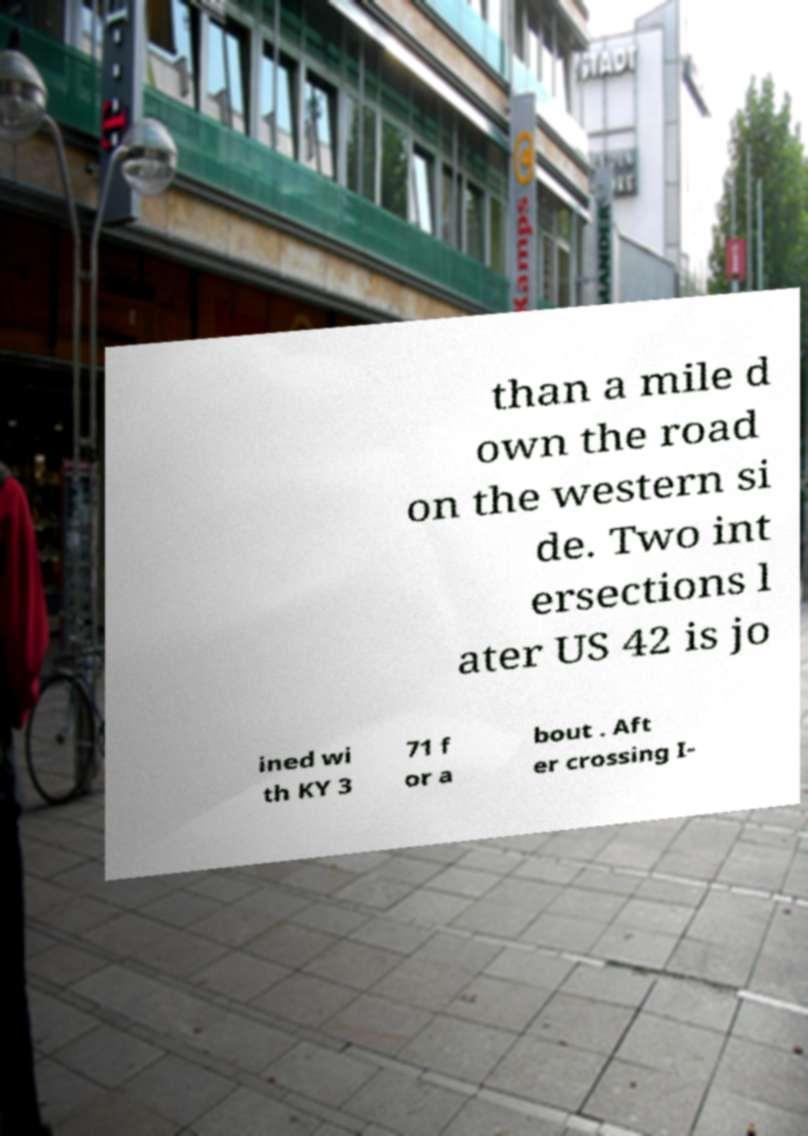For documentation purposes, I need the text within this image transcribed. Could you provide that? than a mile d own the road on the western si de. Two int ersections l ater US 42 is jo ined wi th KY 3 71 f or a bout . Aft er crossing I- 